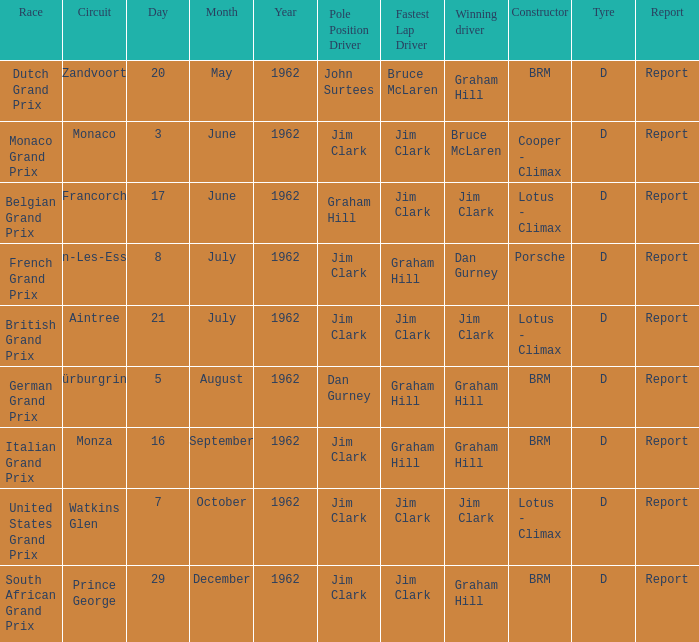What is the tyre on the race where Bruce Mclaren had the fastest lap? D. 